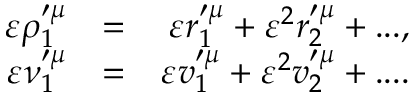Convert formula to latex. <formula><loc_0><loc_0><loc_500><loc_500>\begin{array} { r l r } { \varepsilon \rho _ { 1 } ^ { \prime \mu } } & { = } & { \varepsilon r _ { 1 } ^ { \prime \mu } + \varepsilon ^ { 2 } r _ { 2 } ^ { \prime \mu } + \dots , } \\ { \varepsilon \nu _ { 1 } ^ { \prime \mu } } & { = } & { \varepsilon v _ { 1 } ^ { \prime \mu } + \varepsilon ^ { 2 } v _ { 2 } ^ { \prime \mu } + \cdots } \end{array}</formula> 